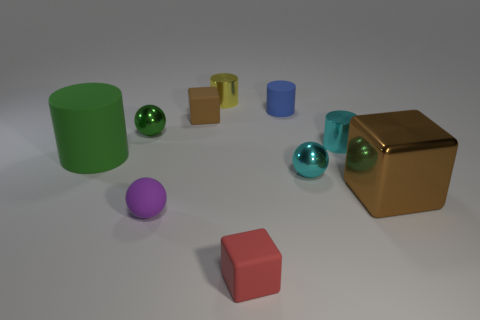Subtract 1 cylinders. How many cylinders are left? 3 Subtract all balls. How many objects are left? 7 Add 8 small purple objects. How many small purple objects are left? 9 Add 7 small blue things. How many small blue things exist? 8 Subtract 0 yellow spheres. How many objects are left? 10 Subtract all metallic spheres. Subtract all green metal balls. How many objects are left? 7 